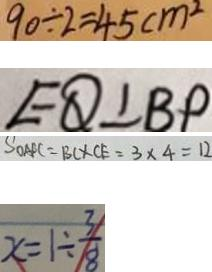<formula> <loc_0><loc_0><loc_500><loc_500>9 0 \div 2 = 4 5 c m ^ { 2 } 
 E Q \bot B P 
 S _ { O A F C } = B C \times C E = 3 \times 4 = 1 2 
 x = 1 \div \frac { 3 } { 8 }</formula> 